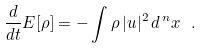Convert formula to latex. <formula><loc_0><loc_0><loc_500><loc_500>\frac { d } { d t } E [ \rho ] = - \int \rho \, | u | ^ { 2 } \, d \, ^ { n } x \ \, .</formula> 